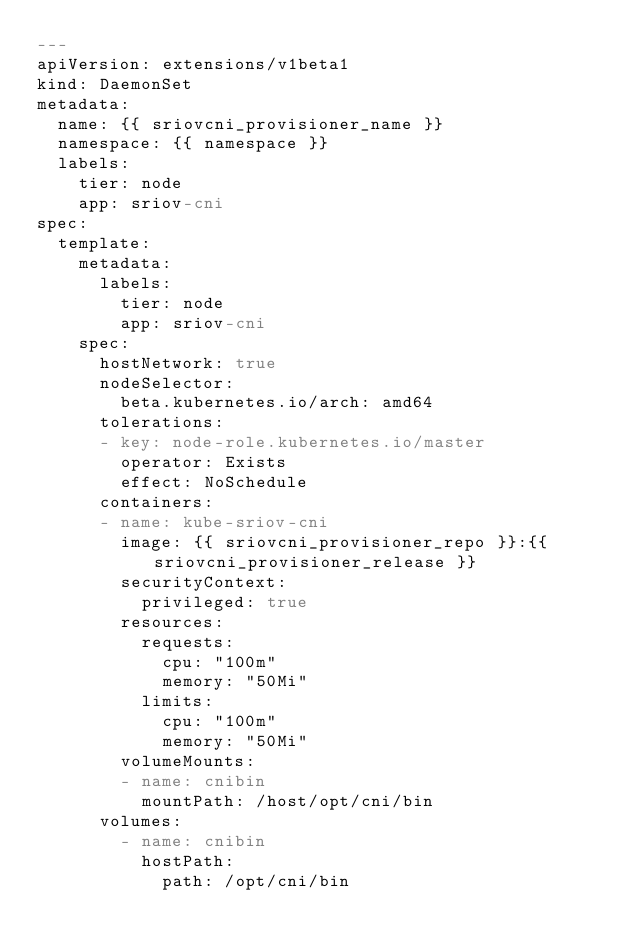Convert code to text. <code><loc_0><loc_0><loc_500><loc_500><_YAML_>---
apiVersion: extensions/v1beta1
kind: DaemonSet
metadata:
  name: {{ sriovcni_provisioner_name }}
  namespace: {{ namespace }}
  labels:
    tier: node
    app: sriov-cni
spec:
  template:
    metadata:
      labels:
        tier: node
        app: sriov-cni
    spec:
      hostNetwork: true
      nodeSelector:
        beta.kubernetes.io/arch: amd64
      tolerations:
      - key: node-role.kubernetes.io/master
        operator: Exists
        effect: NoSchedule
      containers:
      - name: kube-sriov-cni
        image: {{ sriovcni_provisioner_repo }}:{{ sriovcni_provisioner_release }}
        securityContext:
          privileged: true
        resources:
          requests:
            cpu: "100m"
            memory: "50Mi"
          limits:
            cpu: "100m"
            memory: "50Mi"
        volumeMounts:
        - name: cnibin
          mountPath: /host/opt/cni/bin
      volumes:
        - name: cnibin
          hostPath:
            path: /opt/cni/bin
</code> 